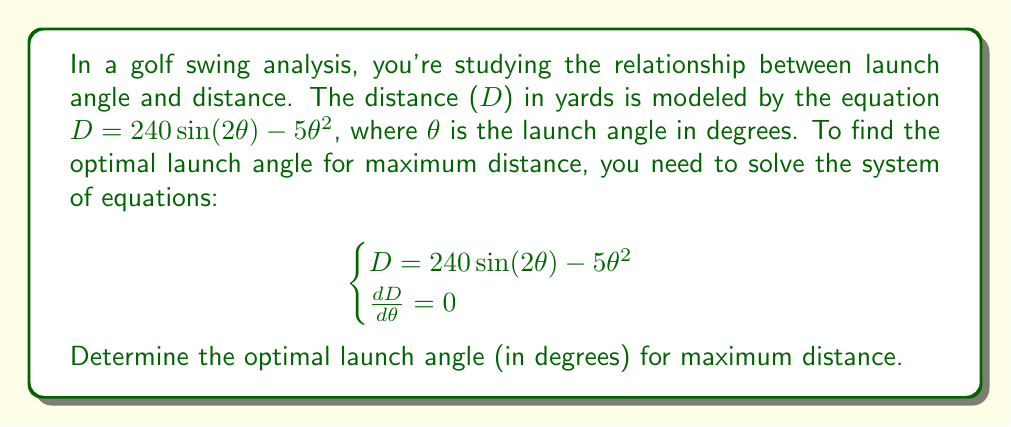Teach me how to tackle this problem. To solve this problem, we'll follow these steps:

1) First, we need to find $\frac{dD}{d\theta}$:
   $$\frac{dD}{d\theta} = 240 \cdot 2\cos(2\theta) - 10\theta$$

2) Now, we set this equal to zero:
   $$240 \cdot 2\cos(2\theta) - 10\theta = 0$$

3) Simplify:
   $$480\cos(2\theta) - 10\theta = 0$$

4) Divide both sides by 10:
   $$48\cos(2\theta) - \theta = 0$$

5) This equation cannot be solved algebraically. We need to use numerical methods or a graphing calculator to find the solution.

6) Using a graphing calculator or numerical method, we find that this equation is satisfied when $\theta \approx 13.9$ degrees.

7) To verify this is a maximum (not a minimum), we can check the second derivative:
   $$\frac{d^2D}{d\theta^2} = -960\sin(2\theta) - 10$$
   
   At $\theta = 13.9$, this is negative, confirming a maximum.

Therefore, the optimal launch angle for maximum distance is approximately 13.9 degrees.
Answer: 13.9 degrees 